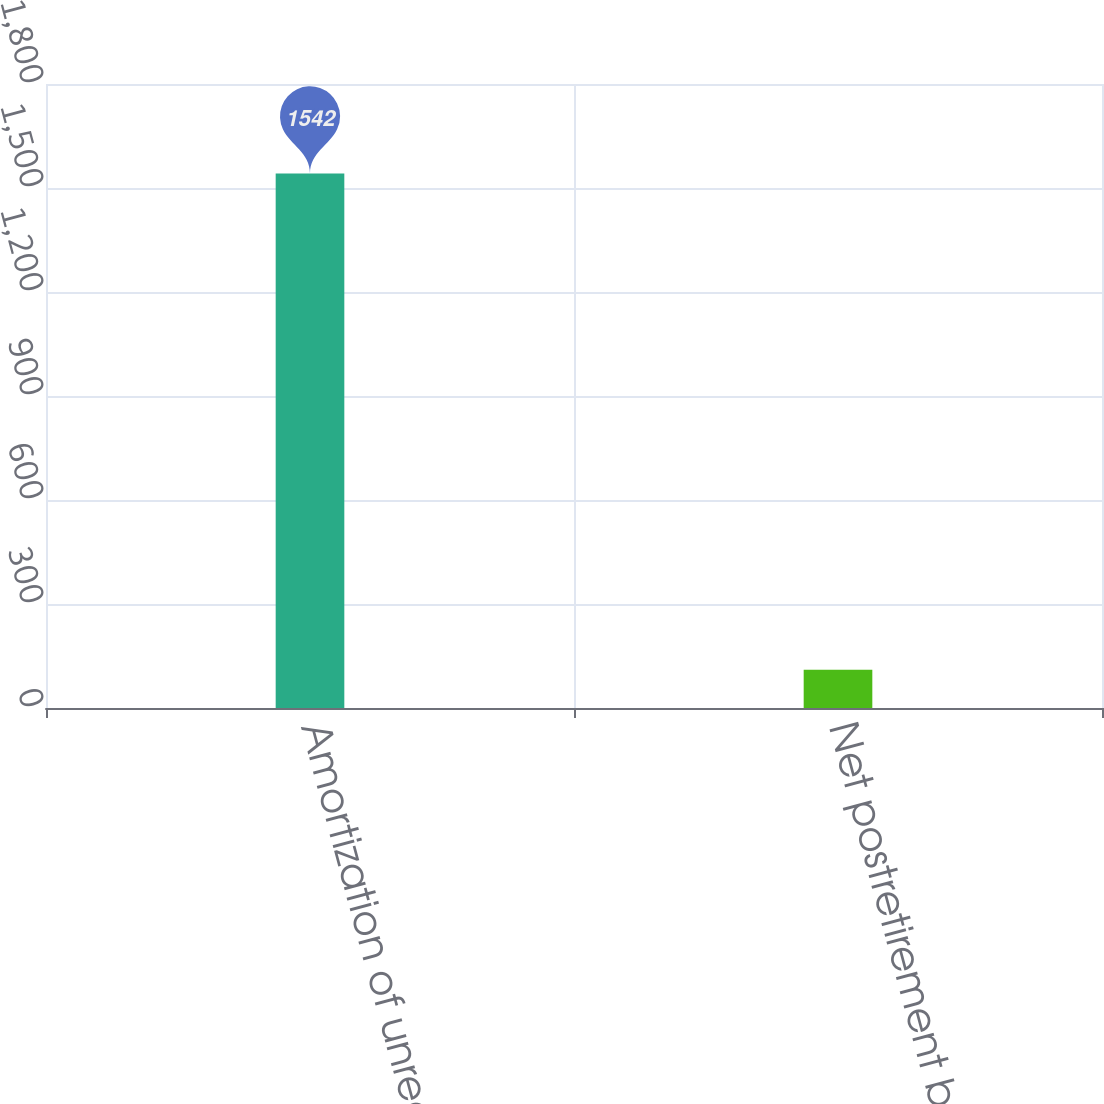Convert chart. <chart><loc_0><loc_0><loc_500><loc_500><bar_chart><fcel>Amortization of unrecognized<fcel>Net postretirement benefit<nl><fcel>1542<fcel>110<nl></chart> 